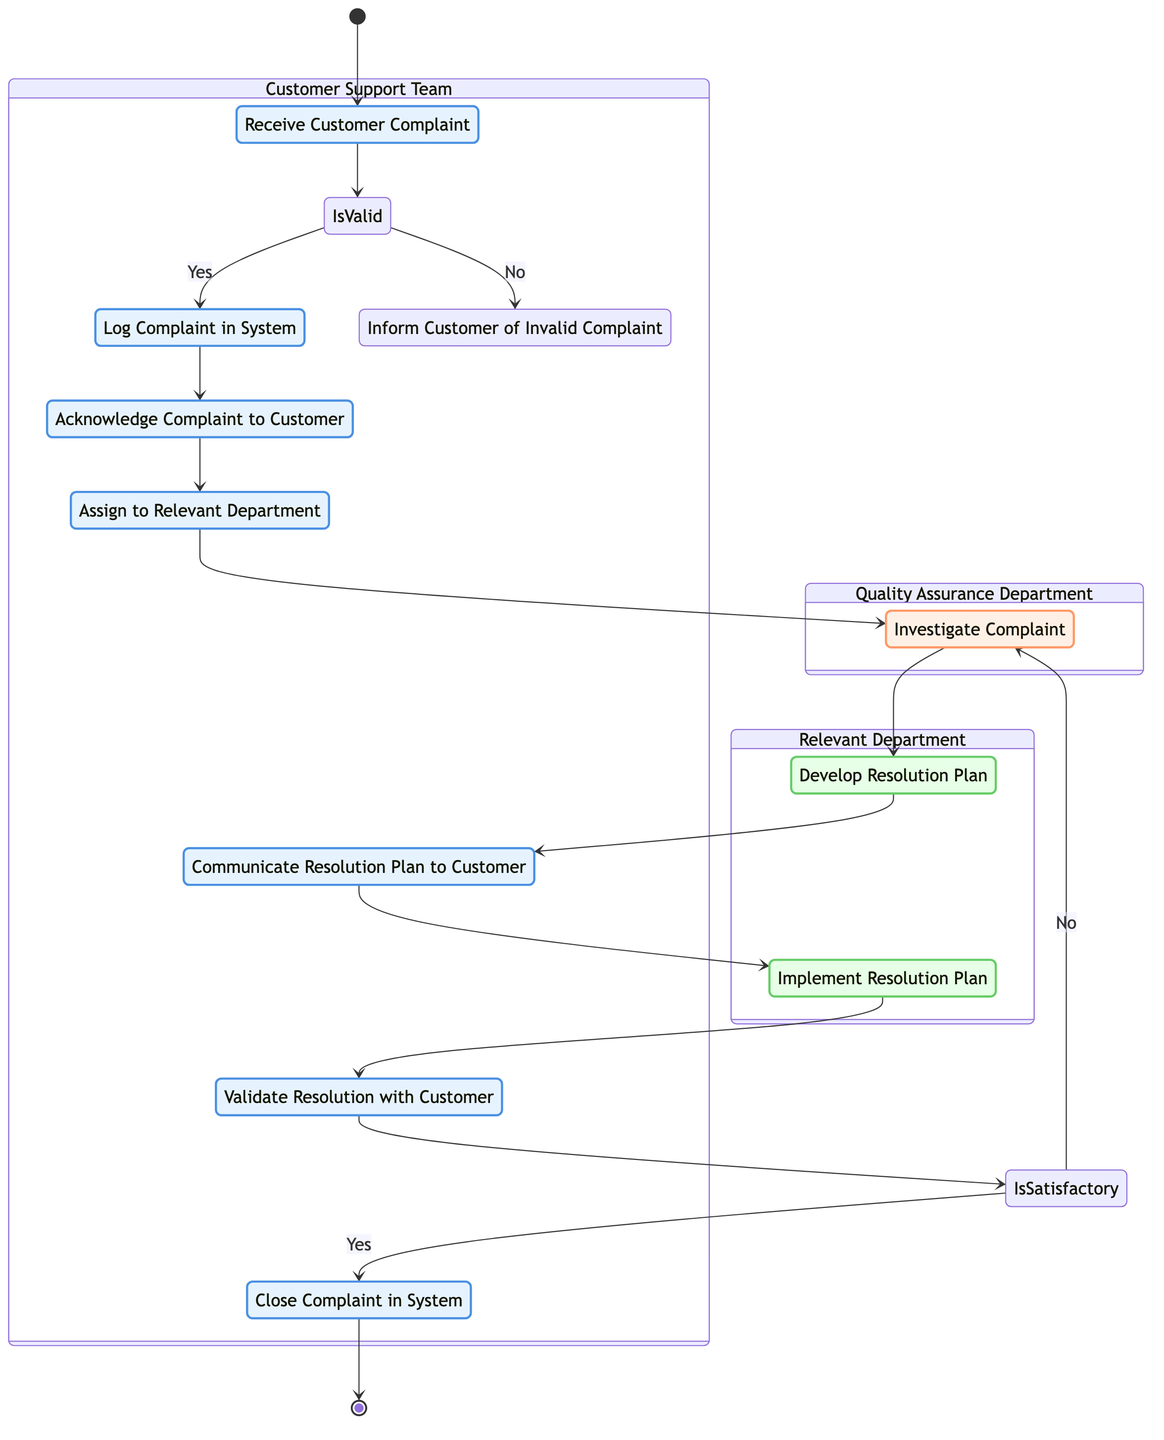What is the starting activity in the process? The starting activity is labeled as "Receive Customer Complaint" in the diagram, which is the entry point for the process.
Answer: Receive Customer Complaint What is the final activity in the process? The final activity is labeled as "Close Complaint in System," indicating that this is the last step in the customer complaint handling process.
Answer: Close Complaint in System How many decision points are there in this diagram? There are two decision points: one for validating the complaint's validity and another for determining if the resolution is satisfactory.
Answer: 2 What activity does the "Relevant Department" handle? The "Relevant Department" is involved in developing the resolution plan and implementing it as part of the complaint resolution process.
Answer: Develop Resolution Plan, Implement Resolution Plan If the complaint is invalid, what action is taken? If the complaint is determined to be invalid, the action taken is to inform the customer of the invalid complaint. This is clearly stated as a response to the decision point regarding the validity of the complaint.
Answer: Inform Customer of Invalid Complaint What happens if the resolution is not satisfactory? If the resolution is not satisfactory, the process indicates to reopen the investigation, which leads back to reassessing the complaint.
Answer: Reopen Investigation Which department is responsible for investigating the complaint? The "Quality Assurance Department" is designated for investigating the complaint, as indicated in the swimlane section of the diagram.
Answer: Quality Assurance Department How does the process begin after receiving the complaint? After receiving the complaint, it moves to log the complaint in the system, following the decision on whether it's valid. This depicts a clear flow from receiving the complaint to taking action based on its validity.
Answer: Log Complaint in System 